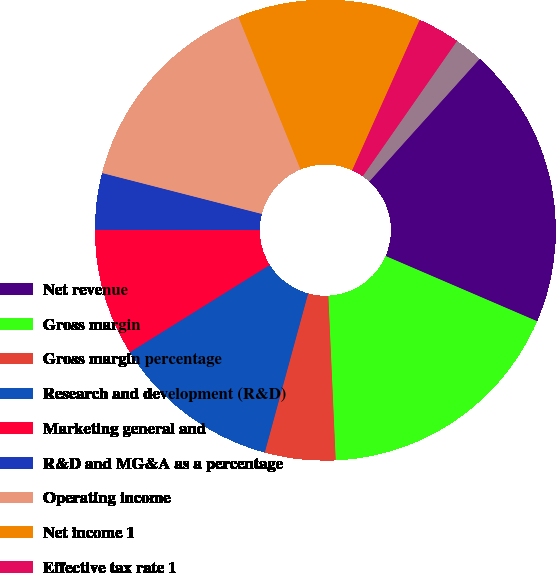Convert chart to OTSL. <chart><loc_0><loc_0><loc_500><loc_500><pie_chart><fcel>Net revenue<fcel>Gross margin<fcel>Gross margin percentage<fcel>Research and development (R&D)<fcel>Marketing general and<fcel>R&D and MG&A as a percentage<fcel>Operating income<fcel>Net income 1<fcel>Effective tax rate 1<fcel>Basic<nl><fcel>19.8%<fcel>17.82%<fcel>4.95%<fcel>11.88%<fcel>8.91%<fcel>3.96%<fcel>14.85%<fcel>12.87%<fcel>2.97%<fcel>1.98%<nl></chart> 